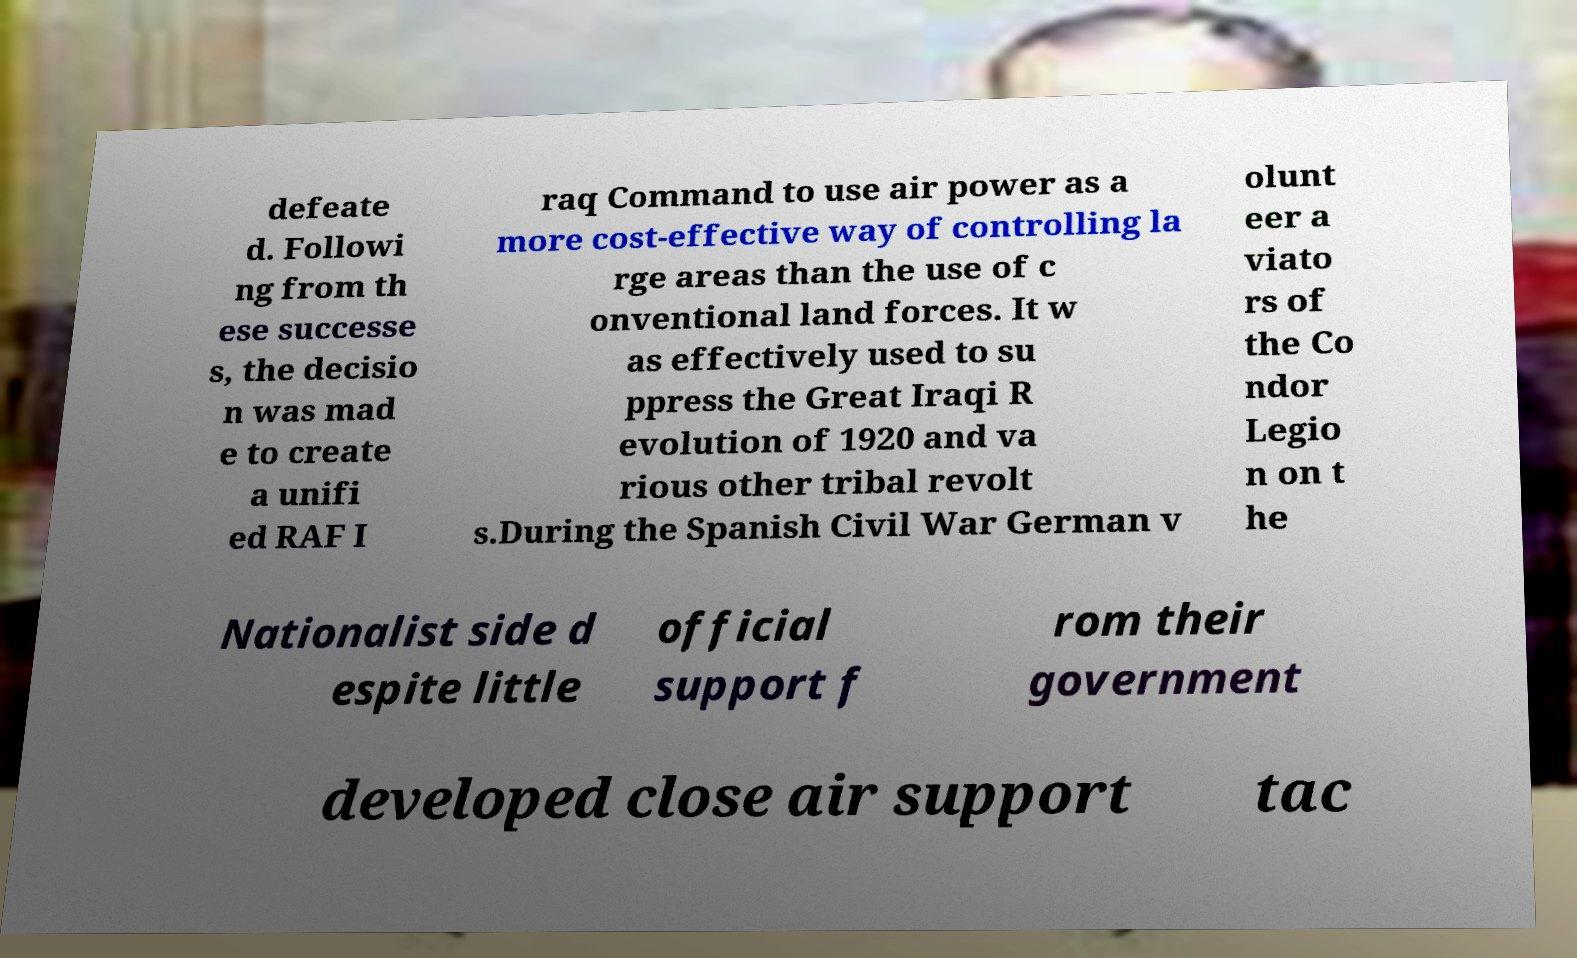What messages or text are displayed in this image? I need them in a readable, typed format. defeate d. Followi ng from th ese successe s, the decisio n was mad e to create a unifi ed RAF I raq Command to use air power as a more cost-effective way of controlling la rge areas than the use of c onventional land forces. It w as effectively used to su ppress the Great Iraqi R evolution of 1920 and va rious other tribal revolt s.During the Spanish Civil War German v olunt eer a viato rs of the Co ndor Legio n on t he Nationalist side d espite little official support f rom their government developed close air support tac 